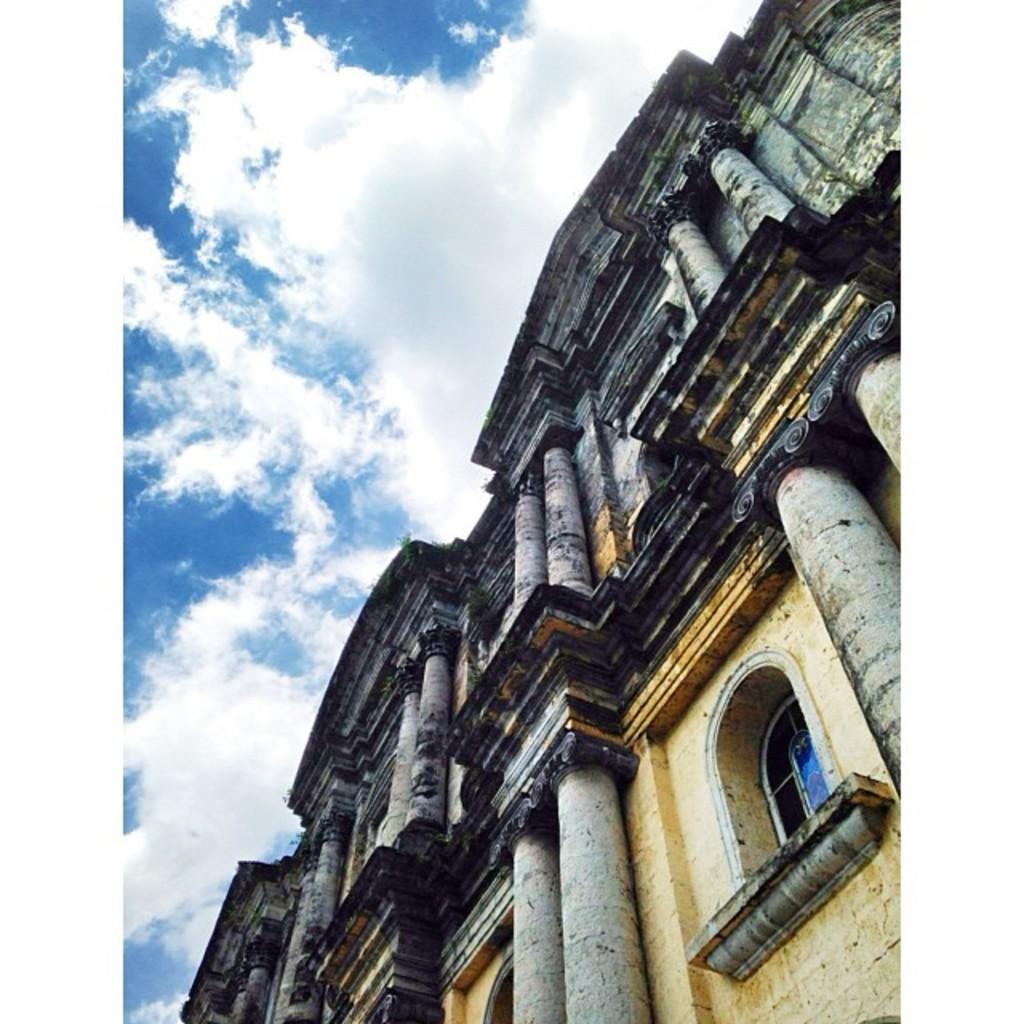What type of structure is present in the image? There is a building in the image. What architectural feature can be seen on the building? The building has pillars. Is there any opening in the building visible in the image? Yes, there is a window on the building. What can be seen on the left side of the image? The sky is visible on the left side of the image. What type of disease is affecting the stem of the plant in the image? There is no plant or stem present in the image; it features a building with pillars and a window. 